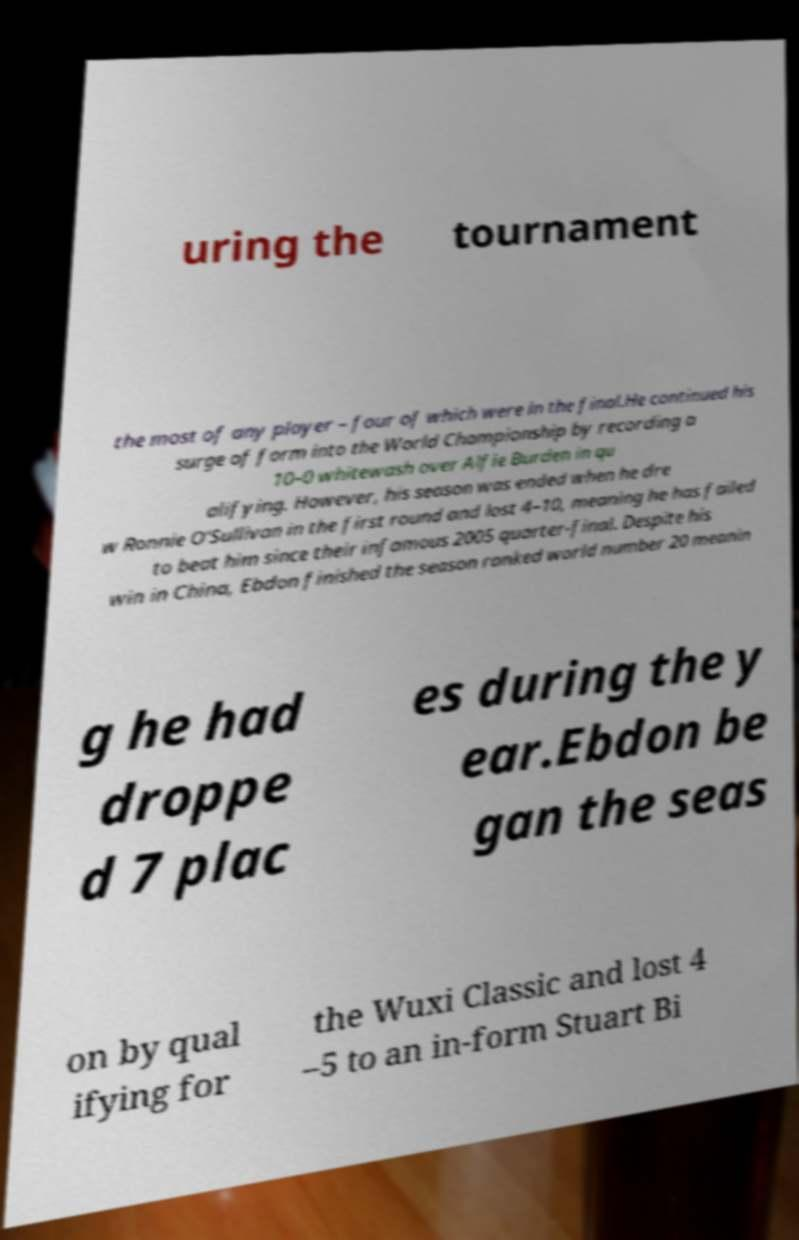I need the written content from this picture converted into text. Can you do that? uring the tournament the most of any player – four of which were in the final.He continued his surge of form into the World Championship by recording a 10–0 whitewash over Alfie Burden in qu alifying. However, his season was ended when he dre w Ronnie O'Sullivan in the first round and lost 4–10, meaning he has failed to beat him since their infamous 2005 quarter-final. Despite his win in China, Ebdon finished the season ranked world number 20 meanin g he had droppe d 7 plac es during the y ear.Ebdon be gan the seas on by qual ifying for the Wuxi Classic and lost 4 –5 to an in-form Stuart Bi 